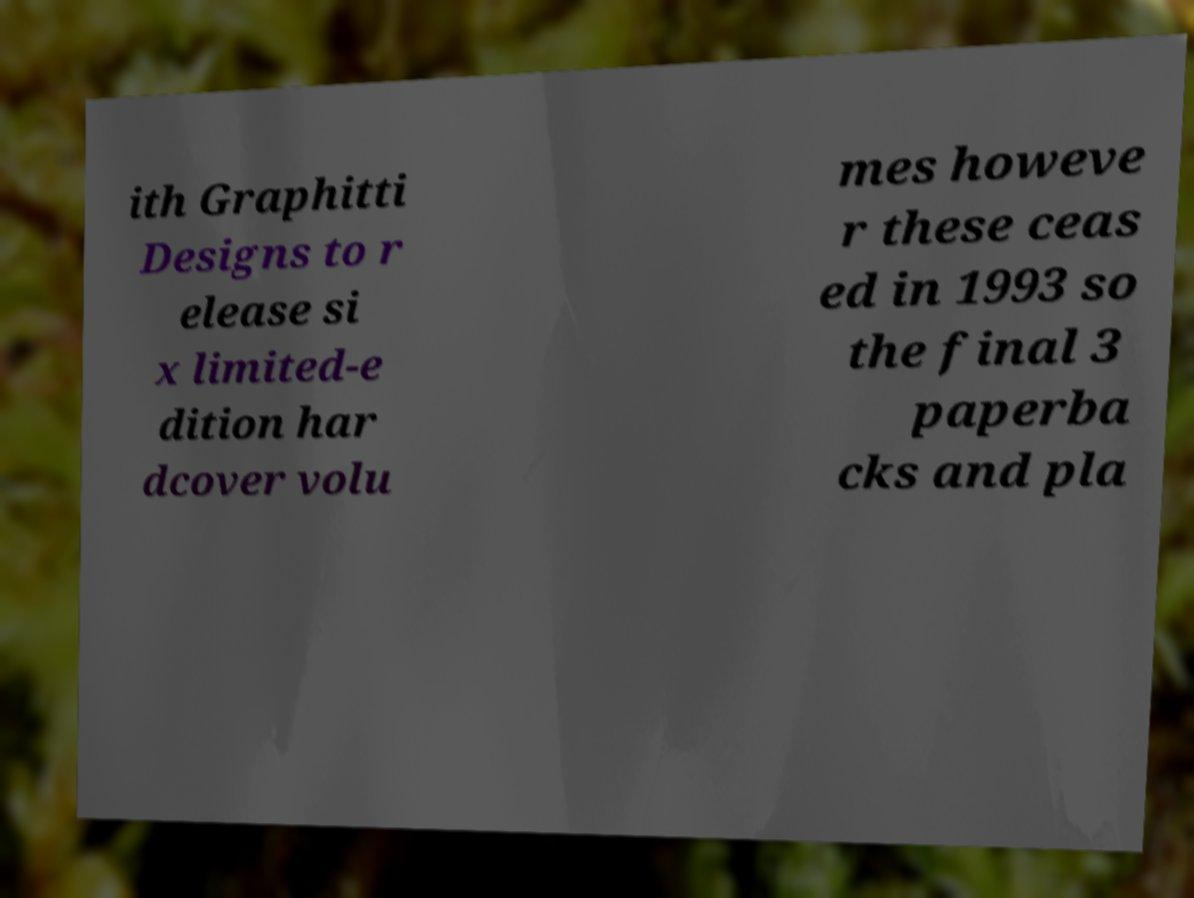Can you accurately transcribe the text from the provided image for me? ith Graphitti Designs to r elease si x limited-e dition har dcover volu mes howeve r these ceas ed in 1993 so the final 3 paperba cks and pla 